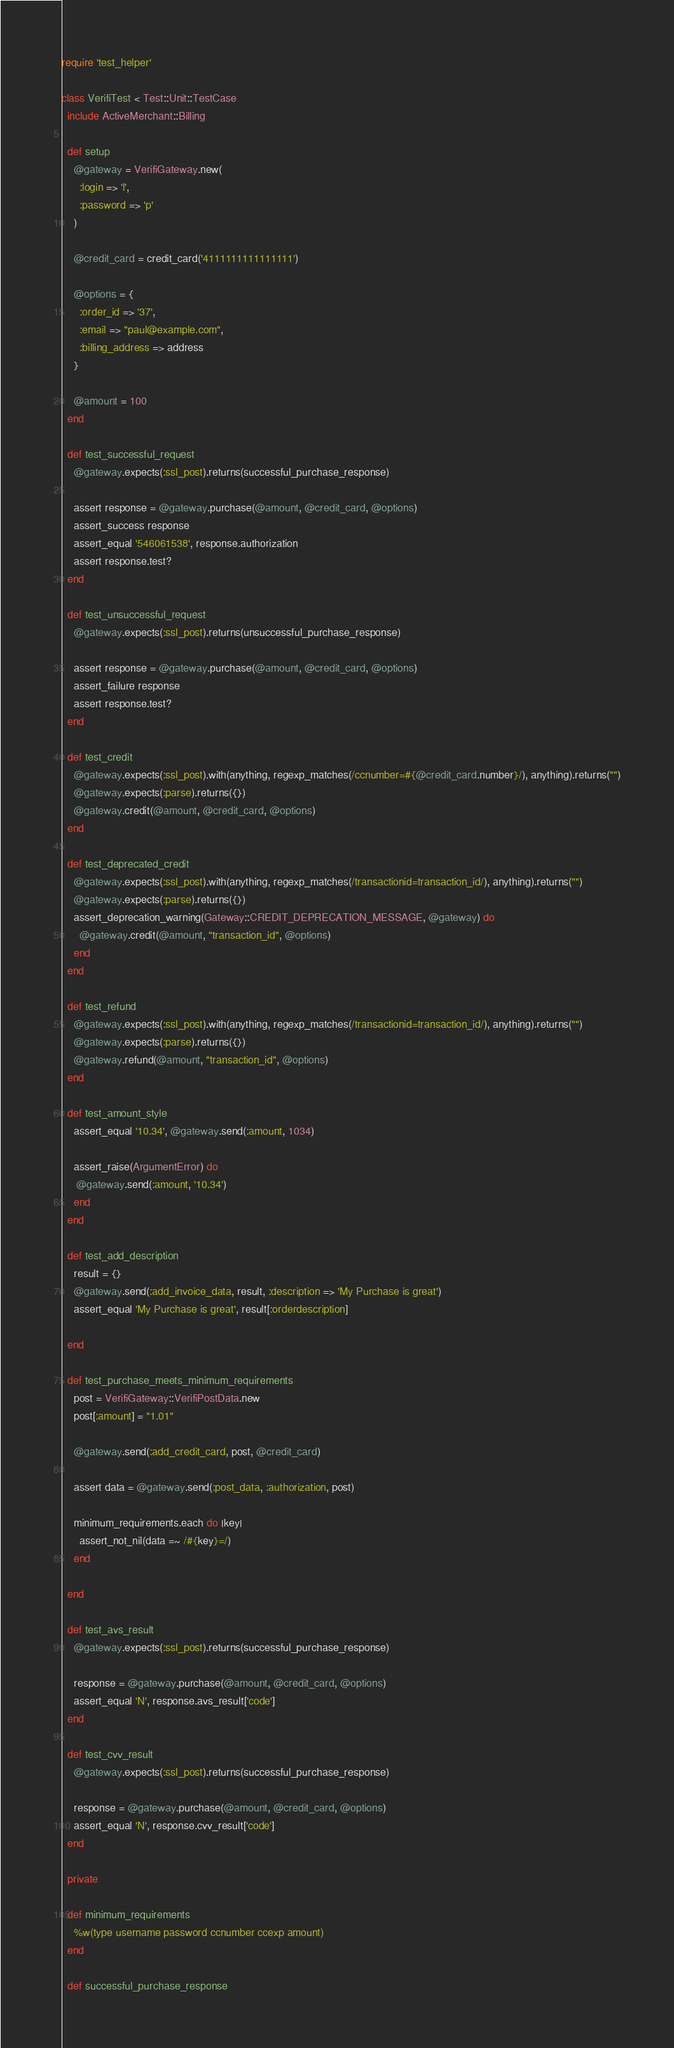<code> <loc_0><loc_0><loc_500><loc_500><_Ruby_>require 'test_helper'

class VerifiTest < Test::Unit::TestCase
  include ActiveMerchant::Billing

  def setup
    @gateway = VerifiGateway.new(
      :login => 'l',
      :password => 'p'
    )
    
    @credit_card = credit_card('4111111111111111')
    
    @options = {
      :order_id => '37',
      :email => "paul@example.com",   
      :billing_address => address     
    }
    
    @amount = 100
  end

  def test_successful_request
    @gateway.expects(:ssl_post).returns(successful_purchase_response)

    assert response = @gateway.purchase(@amount, @credit_card, @options)
    assert_success response
    assert_equal '546061538', response.authorization
    assert response.test?
  end

  def test_unsuccessful_request
    @gateway.expects(:ssl_post).returns(unsuccessful_purchase_response)

    assert response = @gateway.purchase(@amount, @credit_card, @options)
    assert_failure response
    assert response.test?
  end
  
  def test_credit
    @gateway.expects(:ssl_post).with(anything, regexp_matches(/ccnumber=#{@credit_card.number}/), anything).returns("")
    @gateway.expects(:parse).returns({})
    @gateway.credit(@amount, @credit_card, @options)
  end
  
  def test_deprecated_credit
    @gateway.expects(:ssl_post).with(anything, regexp_matches(/transactionid=transaction_id/), anything).returns("")
    @gateway.expects(:parse).returns({})
    assert_deprecation_warning(Gateway::CREDIT_DEPRECATION_MESSAGE, @gateway) do
      @gateway.credit(@amount, "transaction_id", @options)
    end
  end
  
  def test_refund
    @gateway.expects(:ssl_post).with(anything, regexp_matches(/transactionid=transaction_id/), anything).returns("")
    @gateway.expects(:parse).returns({})
    @gateway.refund(@amount, "transaction_id", @options)
  end
  
  def test_amount_style
    assert_equal '10.34', @gateway.send(:amount, 1034)
                                                      
    assert_raise(ArgumentError) do
     @gateway.send(:amount, '10.34')
    end
  end
                                                 
  def test_add_description
    result = {}
    @gateway.send(:add_invoice_data, result, :description => 'My Purchase is great')
    assert_equal 'My Purchase is great', result[:orderdescription]
    
  end

  def test_purchase_meets_minimum_requirements
    post = VerifiGateway::VerifiPostData.new
    post[:amount] = "1.01"                                          
  
    @gateway.send(:add_credit_card, post, @credit_card)
                                                       
    assert data = @gateway.send(:post_data, :authorization, post)
    
    minimum_requirements.each do |key| 
      assert_not_nil(data =~ /#{key}=/)
    end
    
  end
  
  def test_avs_result
    @gateway.expects(:ssl_post).returns(successful_purchase_response)
    
    response = @gateway.purchase(@amount, @credit_card, @options)
    assert_equal 'N', response.avs_result['code']
  end
  
  def test_cvv_result
    @gateway.expects(:ssl_post).returns(successful_purchase_response)
    
    response = @gateway.purchase(@amount, @credit_card, @options)
    assert_equal 'N', response.cvv_result['code']
  end

  private
  
  def minimum_requirements
    %w(type username password ccnumber ccexp amount)
  end
  
  def successful_purchase_response</code> 